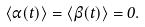Convert formula to latex. <formula><loc_0><loc_0><loc_500><loc_500>\langle \alpha ( t ) \rangle = \langle \beta ( t ) \rangle = 0 .</formula> 